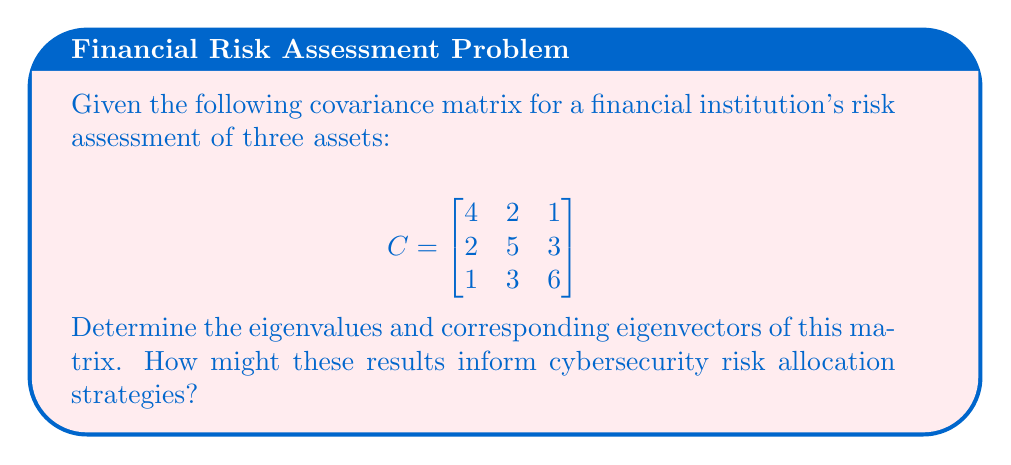Teach me how to tackle this problem. To find the eigenvalues and eigenvectors of the covariance matrix C:

1. Find the eigenvalues by solving the characteristic equation:
   $\det(C - \lambda I) = 0$

   $$\begin{vmatrix}
   4-\lambda & 2 & 1 \\
   2 & 5-\lambda & 3 \\
   1 & 3 & 6-\lambda
   \end{vmatrix} = 0$$

2. Expand the determinant:
   $(4-\lambda)[(5-\lambda)(6-\lambda)-9] - 2[2(6-\lambda)-3] + 1[2\cdot3-(5-\lambda)] = 0$

3. Simplify:
   $\lambda^3 - 15\lambda^2 + 66\lambda - 80 = 0$

4. Solve the cubic equation (using a calculator or computer algebra system):
   $\lambda_1 \approx 8.90$
   $\lambda_2 \approx 4.76$
   $\lambda_3 \approx 1.34$

5. For each eigenvalue $\lambda_i$, find the corresponding eigenvector $v_i$ by solving:
   $(C - \lambda_i I)v_i = 0$

6. Solving these equations gives (normalized):
   $v_1 \approx (0.34, 0.56, 0.75)^T$
   $v_2 \approx (-0.93, 0.17, 0.33)^T$
   $v_3 \approx (0.13, -0.81, 0.57)^T$

Interpretation for cybersecurity risk allocation:
- Eigenvalues represent the variance along principal components.
- Larger eigenvalues indicate directions of higher risk/volatility.
- Eigenvectors show how original variables contribute to these principal components.
- Allocate more resources to areas corresponding to larger eigenvalues and their associated eigenvectors.
Answer: Eigenvalues: $\lambda_1 \approx 8.90$, $\lambda_2 \approx 4.76$, $\lambda_3 \approx 1.34$
Eigenvectors: $v_1 \approx (0.34, 0.56, 0.75)^T$, $v_2 \approx (-0.93, 0.17, 0.33)^T$, $v_3 \approx (0.13, -0.81, 0.57)^T$ 